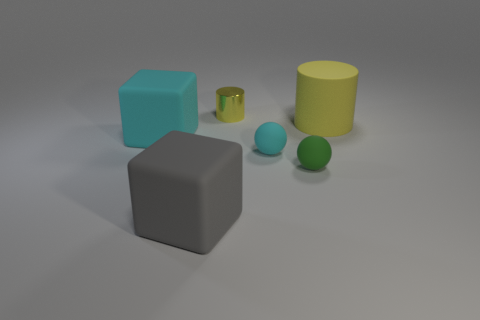Does the tiny cylinder have the same color as the large thing that is on the right side of the big gray matte thing?
Offer a very short reply. Yes. The rubber thing that is the same color as the small metal object is what size?
Provide a short and direct response. Large. Is there a tiny thing of the same color as the rubber cylinder?
Give a very brief answer. Yes. What size is the other block that is made of the same material as the gray cube?
Provide a succinct answer. Large. What number of balls are brown metallic objects or tiny cyan matte things?
Keep it short and to the point. 1. Are there more blocks than big green metallic objects?
Offer a very short reply. Yes. How many green balls have the same size as the yellow rubber cylinder?
Give a very brief answer. 0. What shape is the object that is the same color as the small cylinder?
Keep it short and to the point. Cylinder. What number of things are either big matte things to the left of the matte cylinder or green rubber spheres?
Keep it short and to the point. 3. Is the number of cubes less than the number of small green rubber spheres?
Offer a very short reply. No. 